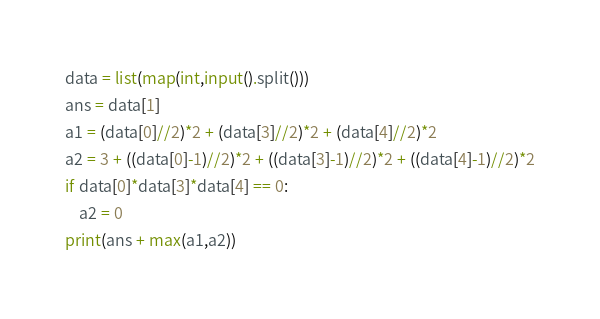<code> <loc_0><loc_0><loc_500><loc_500><_Python_>data = list(map(int,input().split()))
ans = data[1]
a1 = (data[0]//2)*2 + (data[3]//2)*2 + (data[4]//2)*2
a2 = 3 + ((data[0]-1)//2)*2 + ((data[3]-1)//2)*2 + ((data[4]-1)//2)*2
if data[0]*data[3]*data[4] == 0:
    a2 = 0
print(ans + max(a1,a2))
</code> 